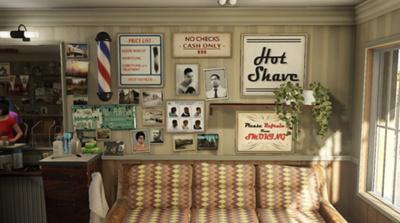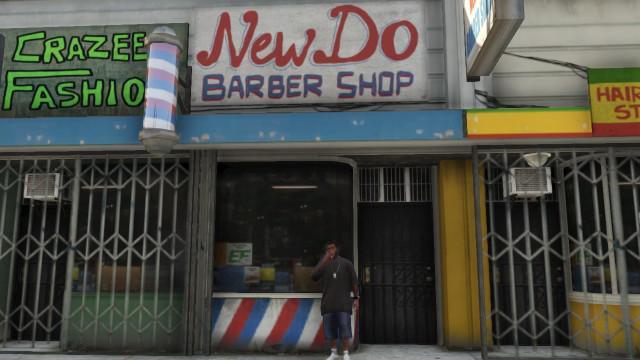The first image is the image on the left, the second image is the image on the right. Examine the images to the left and right. Is the description "One picture contains a man with short hair and facial hair getting his hair cut by an African American woman." accurate? Answer yes or no. No. The first image is the image on the left, the second image is the image on the right. For the images displayed, is the sentence "An image shows a black female barber holding scissors and standing behind a forward-facing male with his hands on armrests." factually correct? Answer yes or no. No. 